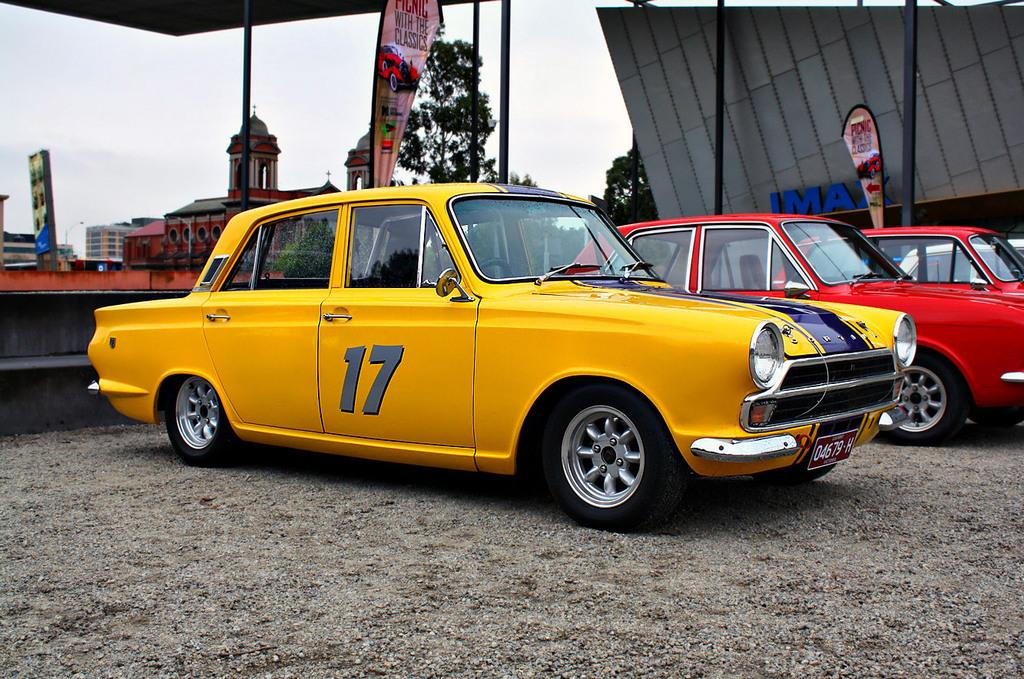What can be seen on the surface in the image? There are vehicles parked on the surface in the image. What type of signage is present in the image? There are banners in the image. What type of vertical structures are present in the image? There are poles in the image. What type of man-made structures are present in the image? There are metal structures in the image. What can be seen in the background of the image? There are buildings, trees, and the sky visible in the background of the image. What type of legal advice can be obtained from the door in the image? There is no door present in the image, and therefore no legal advice can be obtained. What type of crack is visible on the banner in the image? There is no crack visible on the banner in the image. 